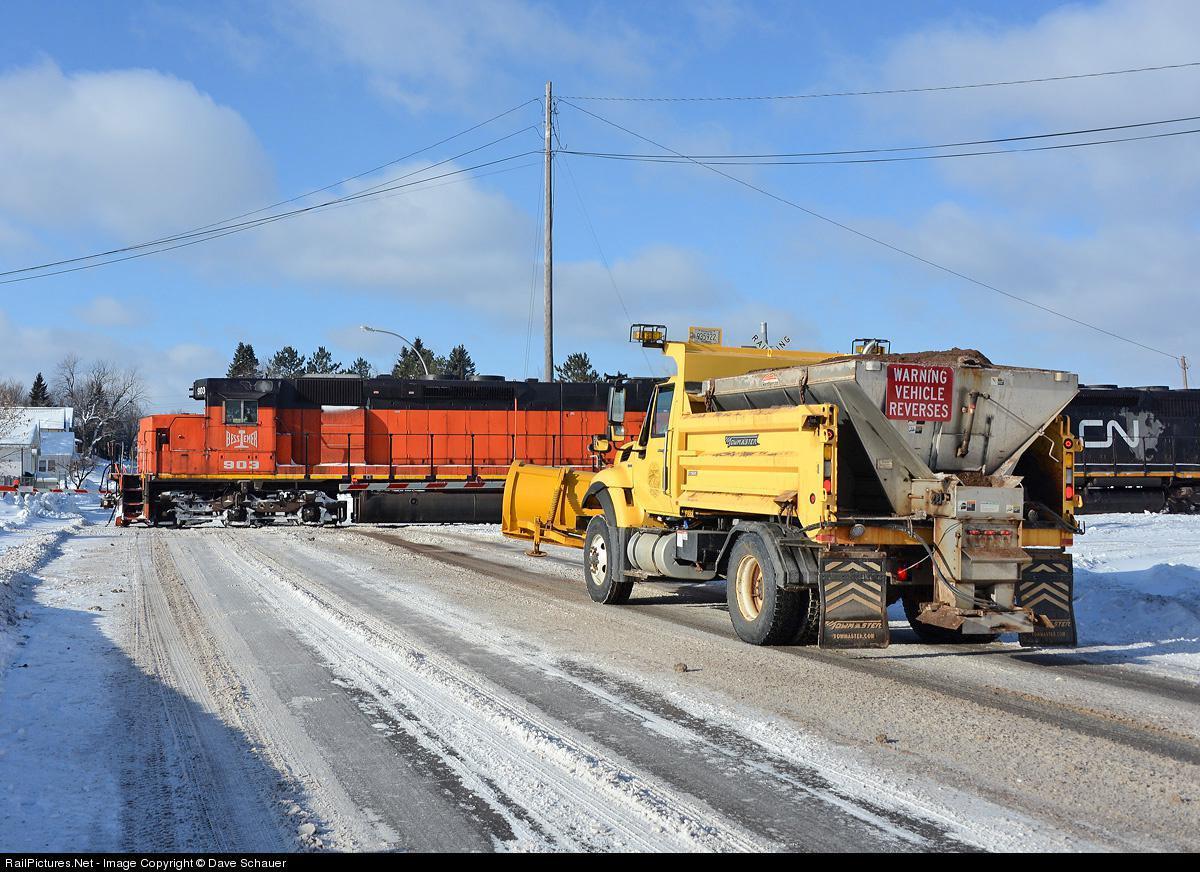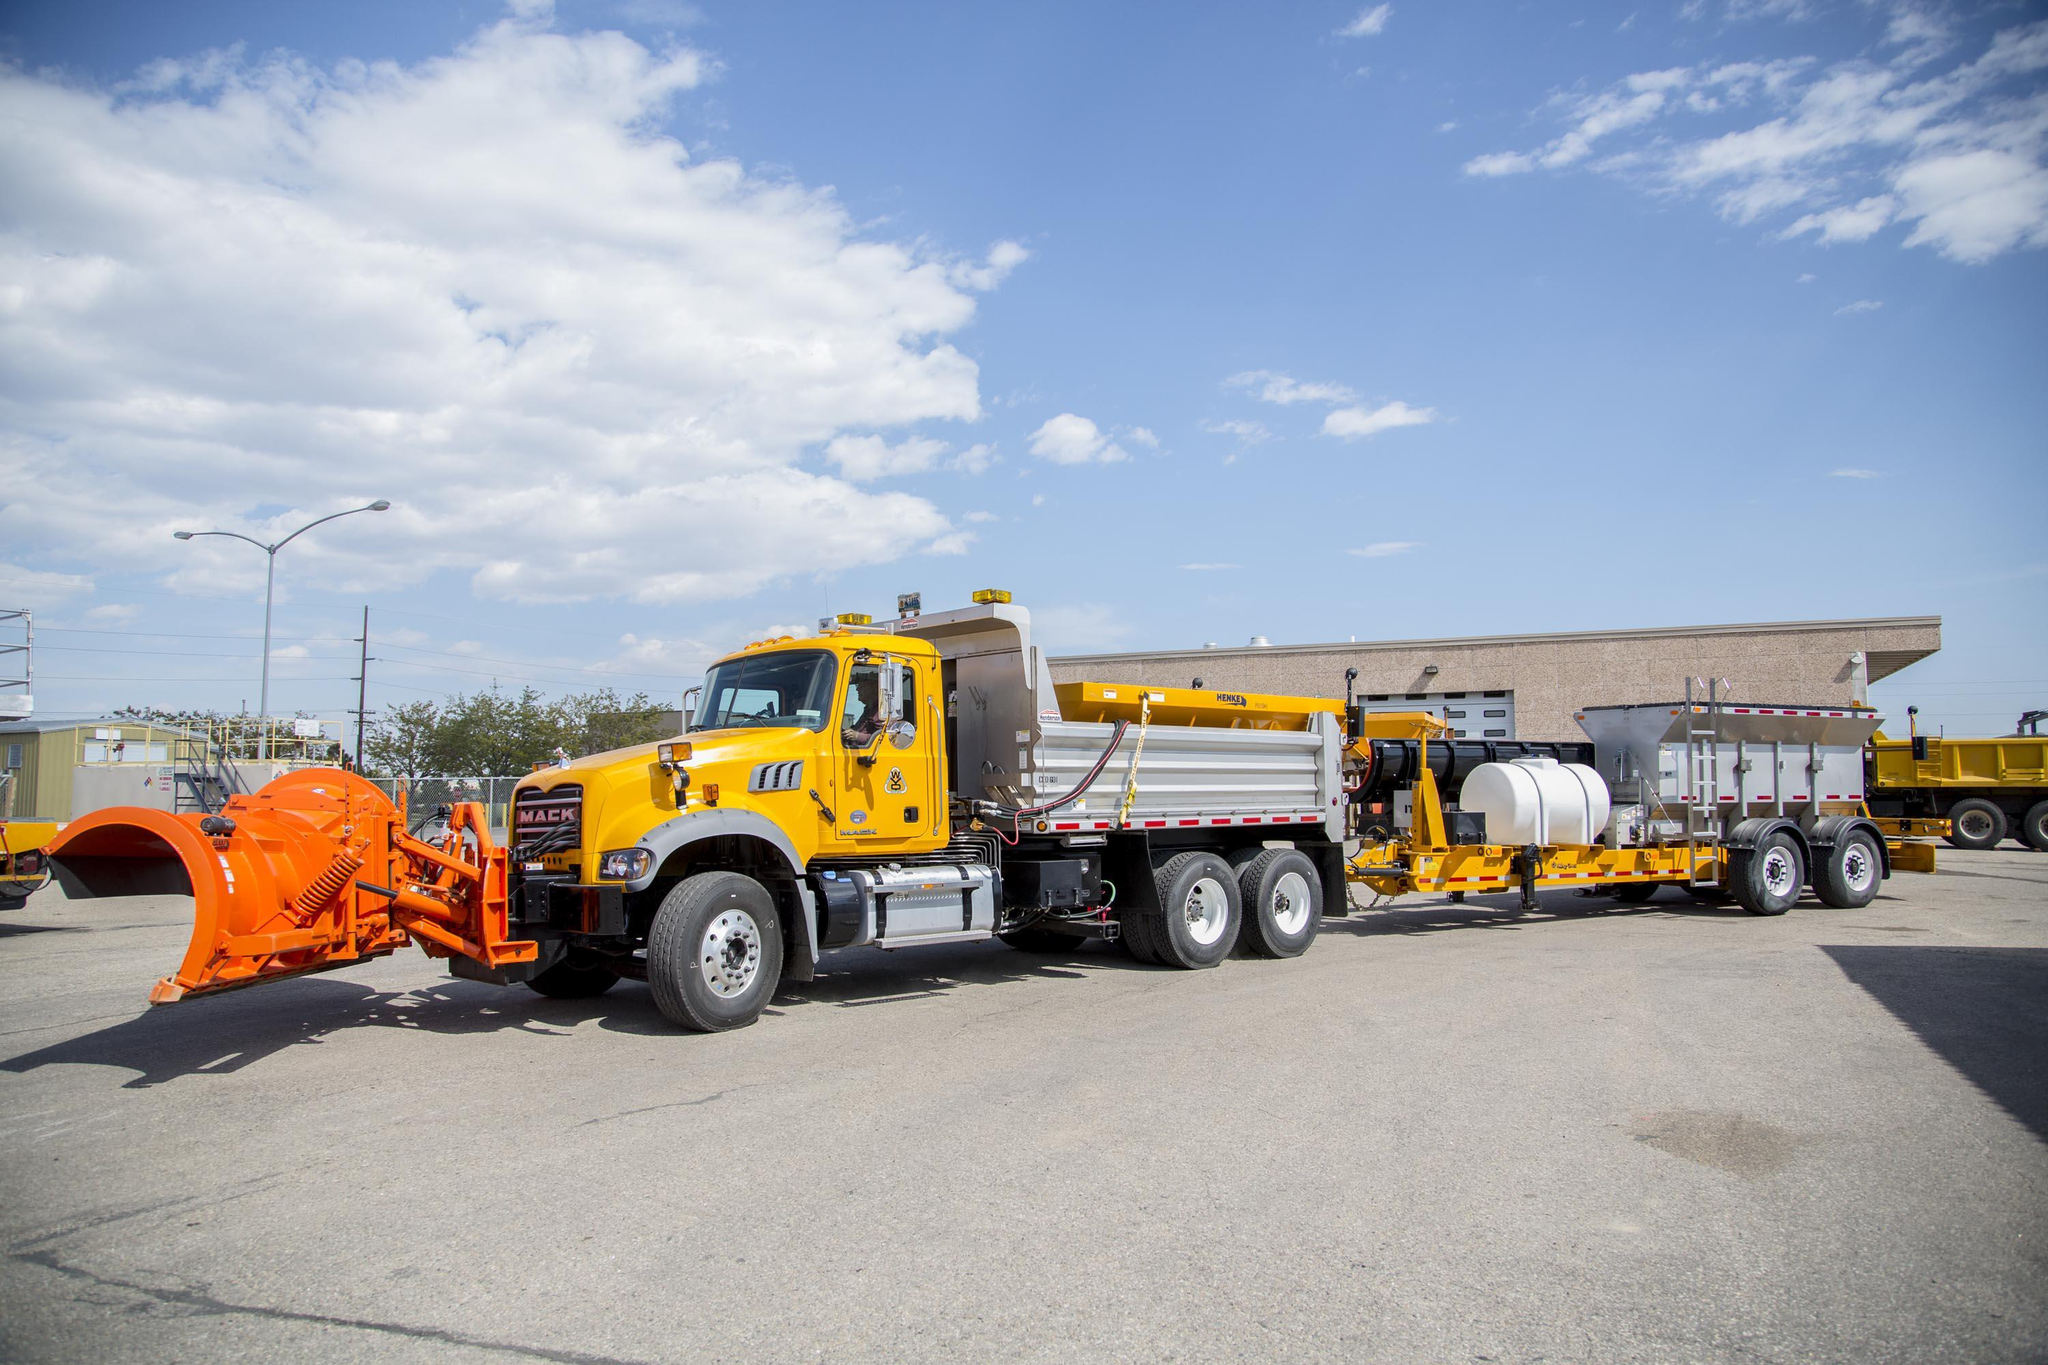The first image is the image on the left, the second image is the image on the right. Assess this claim about the two images: "Snow is visible along the roadside in one of the images featuring a snow plow truck.". Correct or not? Answer yes or no. Yes. The first image is the image on the left, the second image is the image on the right. Considering the images on both sides, is "In one image, at least one yellow truck with snow blade is on a snowy road, while a second image shows snow removal equipment on clear pavement." valid? Answer yes or no. Yes. 